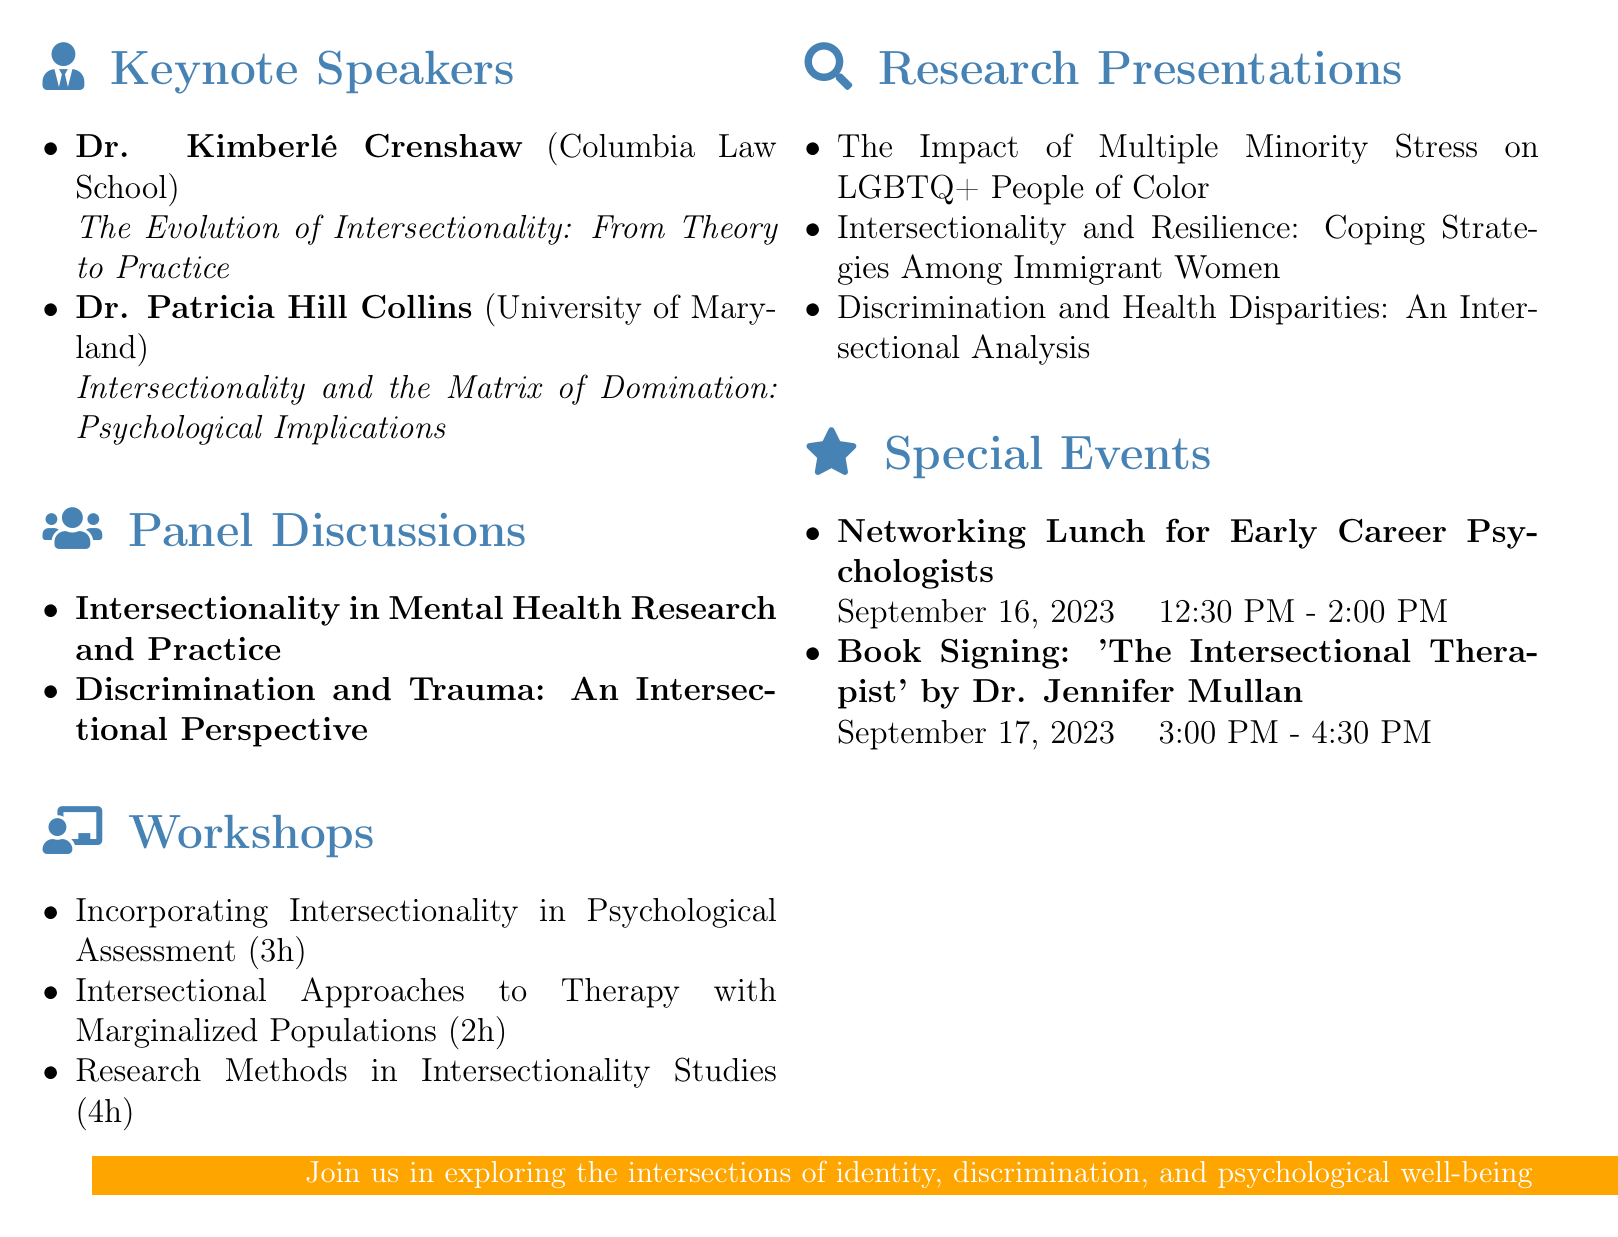What are the dates of the conference? The dates of the conference are explicitly mentioned as September 15-17, 2023.
Answer: September 15-17, 2023 Who is the keynote speaker from Columbia Law School? The document lists Dr. Kimberlé Crenshaw as the keynote speaker affiliated with Columbia Law School.
Answer: Dr. Kimberlé Crenshaw How long is the workshop on Research Methods in Intersectionality Studies? The duration of this workshop is stated as 4 hours.
Answer: 4 hours What is the topic of Dr. Patricia Hill Collins' keynote speech? The agenda specifies that her keynote speech will cover "Intersectionality and the Matrix of Domination: Psychological Implications."
Answer: Intersectionality and the Matrix of Domination: Psychological Implications Which panel focuses on mental health research? The document lists "Intersectionality in Mental Health Research and Practice" as the panel focusing on this topic.
Answer: Intersectionality in Mental Health Research and Practice What special event is scheduled for September 16, 2023? A Networking Lunch for Early Career Psychologists is scheduled for that date.
Answer: Networking Lunch for Early Career Psychologists How many keynote speakers are there? The agenda explicitly states that there are two keynote speakers listed.
Answer: Two What university is Dr. Ilan Meyer affiliated with? The document indicates that Dr. Ilan Meyer is affiliated with UCLA School of Law.
Answer: UCLA School of Law Who is facilitating the workshop on therapy with marginalized populations? The facilitator for this workshop is specified as Dr. Kevin Nadal.
Answer: Dr. Kevin Nadal 